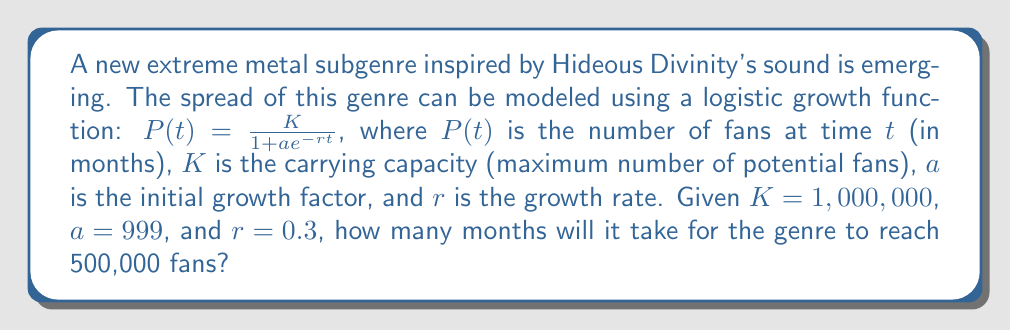Can you solve this math problem? To solve this problem, we'll follow these steps:

1) We need to find $t$ when $P(t) = 500,000$. Let's set up the equation:

   $$500,000 = \frac{1,000,000}{1 + 999e^{-0.3t}}$$

2) Simplify the right side:
   
   $$500,000 = \frac{1,000,000}{1 + 999e^{-0.3t}}$$

3) Multiply both sides by the denominator:
   
   $$500,000(1 + 999e^{-0.3t}) = 1,000,000$$

4) Distribute on the left side:
   
   $$500,000 + 499,500,000e^{-0.3t} = 1,000,000$$

5) Subtract 500,000 from both sides:
   
   $$499,500,000e^{-0.3t} = 500,000$$

6) Divide both sides by 499,500,000:
   
   $$e^{-0.3t} = \frac{1}{999}$$

7) Take the natural log of both sides:
   
   $$-0.3t = \ln(\frac{1}{999})$$

8) Divide both sides by -0.3:
   
   $$t = \frac{\ln(999)}{0.3}$$

9) Calculate the result:
   
   $$t \approx 23.026$$

Since we're dealing with months, we round up to the nearest whole number.
Answer: 24 months 